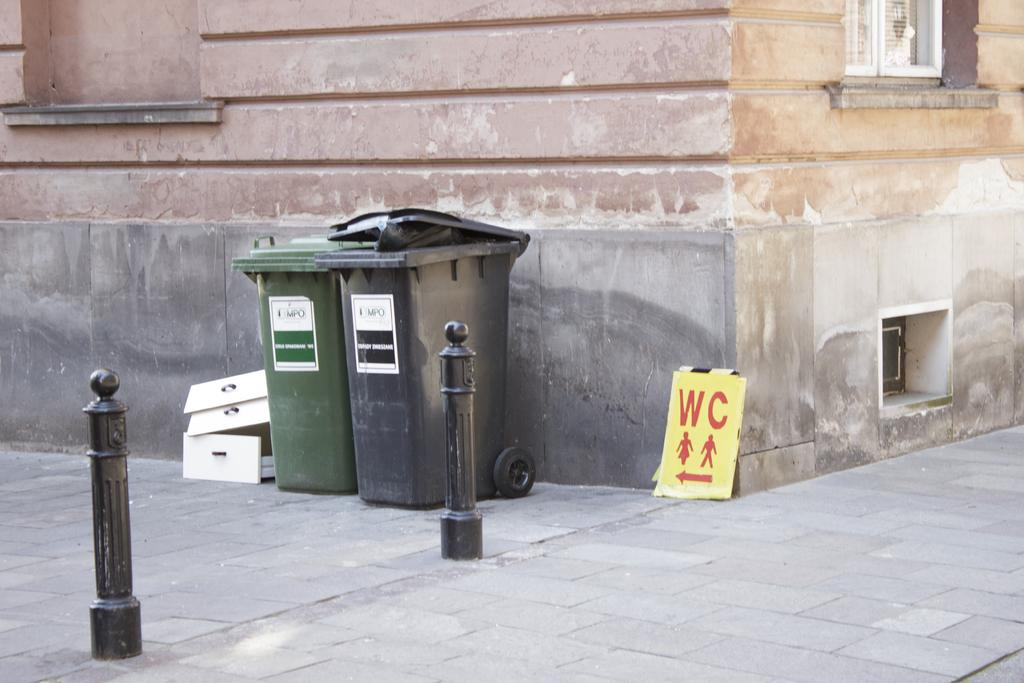<image>
Summarize the visual content of the image. A sign with WC on it in red is near to two trash cans 